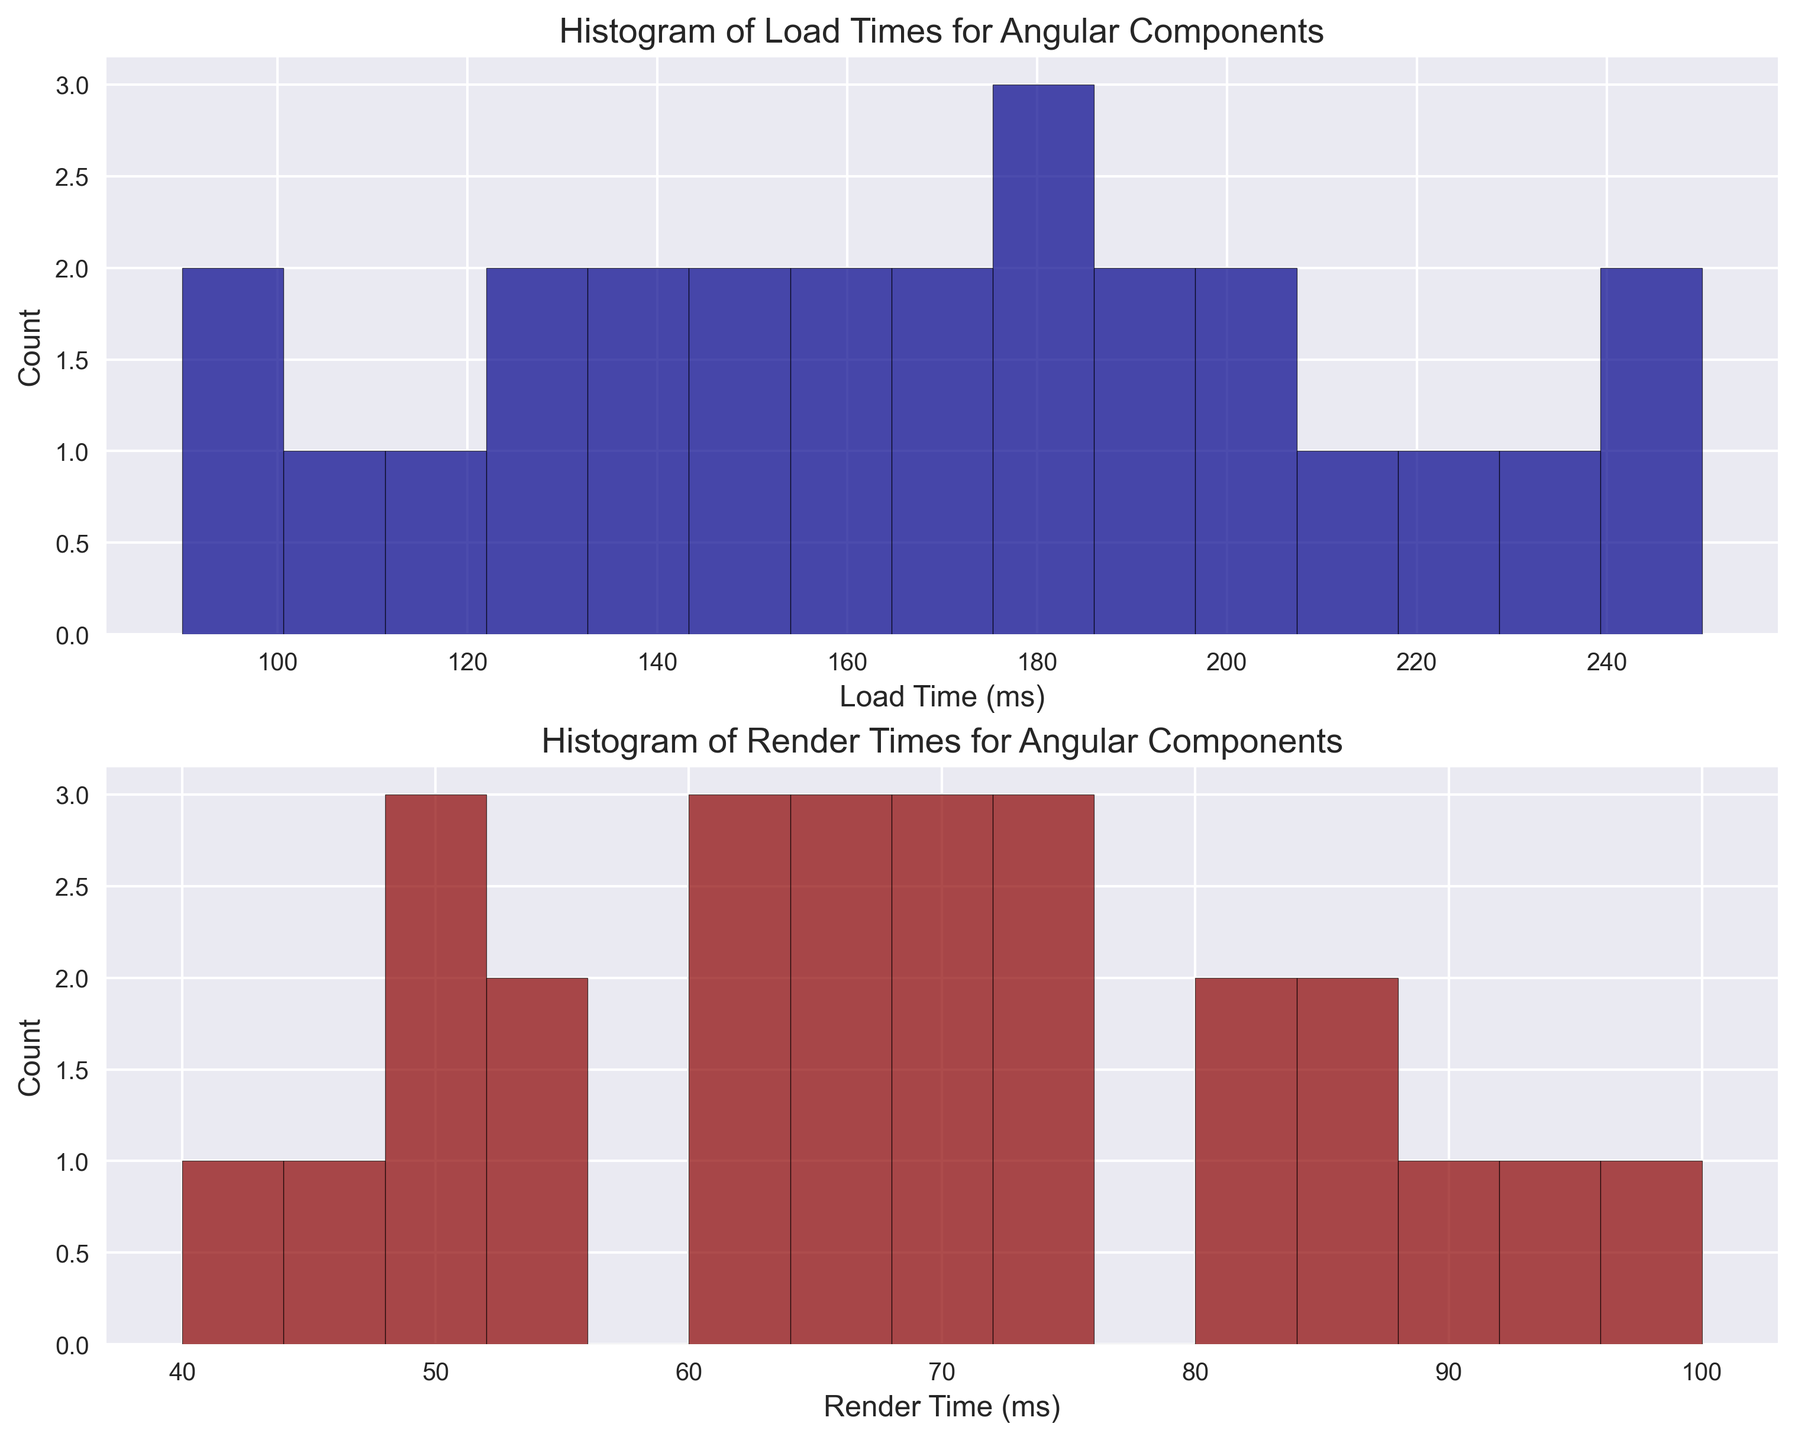Which load time range has the most components? Look at the histogram of Load Times. The tallest bar indicates the load time range with the most components. Identify this bar's range.
Answer: 100-110 ms Which render time range has the least components? Inspect the histogram of Render Times. Identify the shortest bar and note its range, as it represents the render time range with the least components.
Answer: 40-60 ms Which component load times are more frequent, those above 200 ms or below 150 ms? Count the frequency of load times in both ranges from the histogram. Compare the total counts of bars above 200 ms to those below 150 ms.
Answer: Below 150 ms Compare the counts of components with load times in the 90-150 ms range to those in the 150-210 ms range. Which range is higher? Sum the heights of the bars in the 90-150 ms range and then do the same for the 150-210 ms range. Compare these sums.
Answer: 90-150 ms range What is the average load time for the components within the most frequent load time range? The most frequent range is 100-110 ms. Identify the components in this range (ComponentI and ComponentO). Calculate their average load time: (100 + 110) / 2.
Answer: 105 ms How does the distribution of load times visually compare with the distribution of render times? Observe the shapes and spread of both histograms. Compare their peaks, spread widths, and symmetry. Summarize the visual differences and similarities.
Answer: Load times generally spread wider than render times, with a more varied frequency distribution Are there more components with render times below or above 75 ms? Look at the histogram of render times, count the bars below 75 ms and above 75 ms, and compare the frequencies.
Answer: Below 75 ms Identify the range where both load times and render times have similar frequency distributions. Compare both histograms side by side and identify a common range of similar bar heights.
Answer: 50-60 ms Are components with load times between 120 and 160 ms as frequent as those with render times between 70 and 90 ms? Count the bars and their heights (frequency) in the 120-160 ms range for load times and the 70-90 ms range for render times. Compare these counts.
Answer: Yes, both ranges have similar frequencies What is the ratio of the highest frequency in load times to the highest frequency in render times? Identify the tallest bars in both histograms. Note their frequencies. Calculate the ratio of the highest load time frequency to the highest render time frequency.
Answer: 6:5 